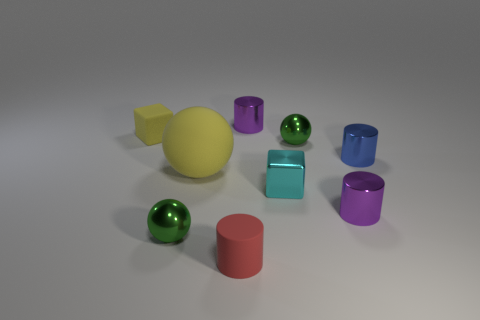There is a shiny cylinder behind the metal ball that is behind the big yellow rubber object; what color is it?
Keep it short and to the point. Purple. Do the purple thing that is behind the tiny blue metallic thing and the small green thing behind the large yellow object have the same shape?
Provide a succinct answer. No. There is a blue metal object that is the same size as the rubber cylinder; what shape is it?
Your answer should be very brief. Cylinder. The tiny block that is the same material as the tiny blue cylinder is what color?
Your answer should be very brief. Cyan. Is the shape of the small yellow object the same as the purple thing behind the blue metal object?
Your answer should be very brief. No. What material is the large sphere that is the same color as the rubber block?
Offer a very short reply. Rubber. There is a cyan thing that is the same size as the yellow rubber cube; what is its material?
Your answer should be very brief. Metal. Are there any balls that have the same color as the metal block?
Ensure brevity in your answer.  No. There is a rubber thing that is behind the tiny rubber cylinder and in front of the yellow cube; what shape is it?
Make the answer very short. Sphere. How many tiny purple things are made of the same material as the small yellow cube?
Your response must be concise. 0. 